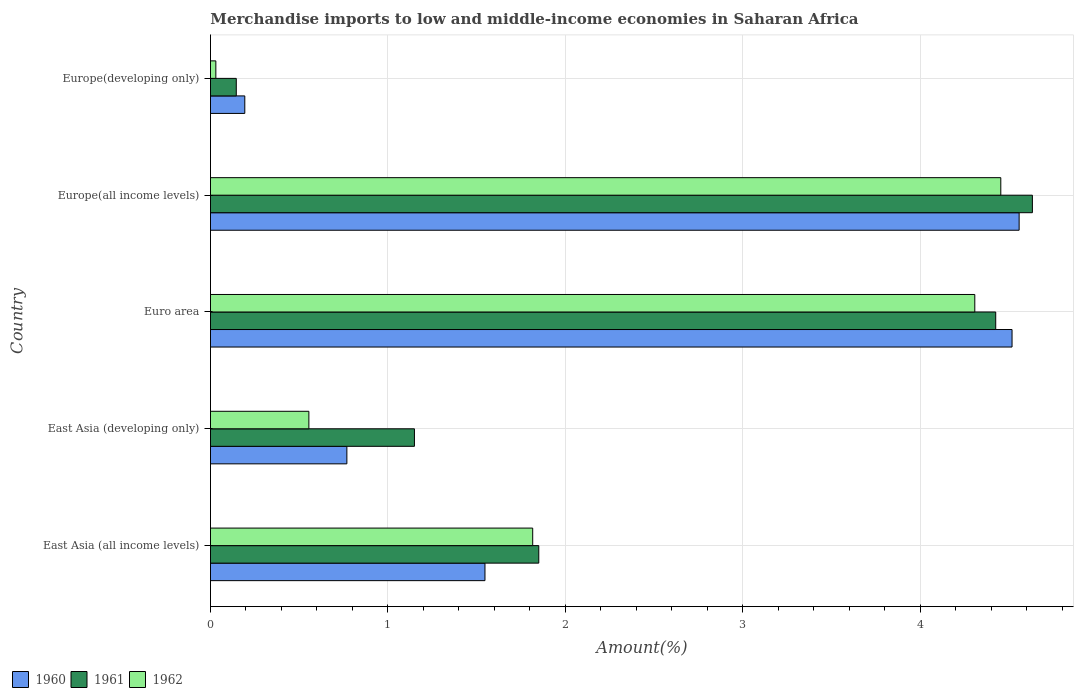How many groups of bars are there?
Your response must be concise. 5. Are the number of bars on each tick of the Y-axis equal?
Offer a very short reply. Yes. How many bars are there on the 2nd tick from the bottom?
Make the answer very short. 3. What is the label of the 4th group of bars from the top?
Ensure brevity in your answer.  East Asia (developing only). In how many cases, is the number of bars for a given country not equal to the number of legend labels?
Provide a succinct answer. 0. What is the percentage of amount earned from merchandise imports in 1962 in Euro area?
Provide a succinct answer. 4.31. Across all countries, what is the maximum percentage of amount earned from merchandise imports in 1962?
Provide a short and direct response. 4.45. Across all countries, what is the minimum percentage of amount earned from merchandise imports in 1962?
Offer a terse response. 0.03. In which country was the percentage of amount earned from merchandise imports in 1962 maximum?
Make the answer very short. Europe(all income levels). In which country was the percentage of amount earned from merchandise imports in 1961 minimum?
Provide a short and direct response. Europe(developing only). What is the total percentage of amount earned from merchandise imports in 1962 in the graph?
Provide a short and direct response. 11.16. What is the difference between the percentage of amount earned from merchandise imports in 1961 in East Asia (developing only) and that in Euro area?
Your answer should be compact. -3.28. What is the difference between the percentage of amount earned from merchandise imports in 1960 in East Asia (all income levels) and the percentage of amount earned from merchandise imports in 1962 in Europe(all income levels)?
Your answer should be very brief. -2.91. What is the average percentage of amount earned from merchandise imports in 1962 per country?
Make the answer very short. 2.23. What is the difference between the percentage of amount earned from merchandise imports in 1960 and percentage of amount earned from merchandise imports in 1961 in Europe(all income levels)?
Give a very brief answer. -0.07. What is the ratio of the percentage of amount earned from merchandise imports in 1961 in Euro area to that in Europe(developing only)?
Your answer should be very brief. 30.42. Is the difference between the percentage of amount earned from merchandise imports in 1960 in East Asia (all income levels) and Euro area greater than the difference between the percentage of amount earned from merchandise imports in 1961 in East Asia (all income levels) and Euro area?
Your answer should be very brief. No. What is the difference between the highest and the second highest percentage of amount earned from merchandise imports in 1961?
Offer a very short reply. 0.21. What is the difference between the highest and the lowest percentage of amount earned from merchandise imports in 1962?
Give a very brief answer. 4.42. What does the 3rd bar from the top in East Asia (developing only) represents?
Your response must be concise. 1960. What does the 2nd bar from the bottom in East Asia (developing only) represents?
Your answer should be compact. 1961. What is the difference between two consecutive major ticks on the X-axis?
Your response must be concise. 1. Are the values on the major ticks of X-axis written in scientific E-notation?
Make the answer very short. No. Does the graph contain any zero values?
Give a very brief answer. No. Where does the legend appear in the graph?
Your answer should be very brief. Bottom left. What is the title of the graph?
Offer a terse response. Merchandise imports to low and middle-income economies in Saharan Africa. Does "1977" appear as one of the legend labels in the graph?
Offer a terse response. No. What is the label or title of the X-axis?
Offer a terse response. Amount(%). What is the Amount(%) of 1960 in East Asia (all income levels)?
Offer a terse response. 1.55. What is the Amount(%) of 1961 in East Asia (all income levels)?
Make the answer very short. 1.85. What is the Amount(%) of 1962 in East Asia (all income levels)?
Give a very brief answer. 1.82. What is the Amount(%) in 1960 in East Asia (developing only)?
Make the answer very short. 0.77. What is the Amount(%) of 1961 in East Asia (developing only)?
Provide a short and direct response. 1.15. What is the Amount(%) in 1962 in East Asia (developing only)?
Keep it short and to the point. 0.55. What is the Amount(%) in 1960 in Euro area?
Your answer should be very brief. 4.52. What is the Amount(%) of 1961 in Euro area?
Keep it short and to the point. 4.43. What is the Amount(%) in 1962 in Euro area?
Offer a very short reply. 4.31. What is the Amount(%) of 1960 in Europe(all income levels)?
Your response must be concise. 4.56. What is the Amount(%) of 1961 in Europe(all income levels)?
Keep it short and to the point. 4.63. What is the Amount(%) of 1962 in Europe(all income levels)?
Make the answer very short. 4.45. What is the Amount(%) in 1960 in Europe(developing only)?
Provide a succinct answer. 0.19. What is the Amount(%) of 1961 in Europe(developing only)?
Give a very brief answer. 0.15. What is the Amount(%) of 1962 in Europe(developing only)?
Provide a short and direct response. 0.03. Across all countries, what is the maximum Amount(%) in 1960?
Make the answer very short. 4.56. Across all countries, what is the maximum Amount(%) of 1961?
Your answer should be very brief. 4.63. Across all countries, what is the maximum Amount(%) of 1962?
Ensure brevity in your answer.  4.45. Across all countries, what is the minimum Amount(%) in 1960?
Offer a terse response. 0.19. Across all countries, what is the minimum Amount(%) of 1961?
Your answer should be very brief. 0.15. Across all countries, what is the minimum Amount(%) of 1962?
Make the answer very short. 0.03. What is the total Amount(%) in 1960 in the graph?
Keep it short and to the point. 11.58. What is the total Amount(%) in 1961 in the graph?
Provide a short and direct response. 12.2. What is the total Amount(%) of 1962 in the graph?
Offer a terse response. 11.16. What is the difference between the Amount(%) of 1960 in East Asia (all income levels) and that in East Asia (developing only)?
Your response must be concise. 0.78. What is the difference between the Amount(%) of 1961 in East Asia (all income levels) and that in East Asia (developing only)?
Your answer should be very brief. 0.7. What is the difference between the Amount(%) of 1962 in East Asia (all income levels) and that in East Asia (developing only)?
Offer a terse response. 1.26. What is the difference between the Amount(%) of 1960 in East Asia (all income levels) and that in Euro area?
Your response must be concise. -2.97. What is the difference between the Amount(%) in 1961 in East Asia (all income levels) and that in Euro area?
Provide a succinct answer. -2.58. What is the difference between the Amount(%) in 1962 in East Asia (all income levels) and that in Euro area?
Your response must be concise. -2.49. What is the difference between the Amount(%) in 1960 in East Asia (all income levels) and that in Europe(all income levels)?
Provide a succinct answer. -3.01. What is the difference between the Amount(%) of 1961 in East Asia (all income levels) and that in Europe(all income levels)?
Keep it short and to the point. -2.78. What is the difference between the Amount(%) of 1962 in East Asia (all income levels) and that in Europe(all income levels)?
Your response must be concise. -2.64. What is the difference between the Amount(%) of 1960 in East Asia (all income levels) and that in Europe(developing only)?
Give a very brief answer. 1.35. What is the difference between the Amount(%) in 1961 in East Asia (all income levels) and that in Europe(developing only)?
Make the answer very short. 1.7. What is the difference between the Amount(%) of 1962 in East Asia (all income levels) and that in Europe(developing only)?
Your answer should be very brief. 1.79. What is the difference between the Amount(%) of 1960 in East Asia (developing only) and that in Euro area?
Your answer should be compact. -3.75. What is the difference between the Amount(%) of 1961 in East Asia (developing only) and that in Euro area?
Provide a succinct answer. -3.28. What is the difference between the Amount(%) of 1962 in East Asia (developing only) and that in Euro area?
Keep it short and to the point. -3.75. What is the difference between the Amount(%) of 1960 in East Asia (developing only) and that in Europe(all income levels)?
Give a very brief answer. -3.79. What is the difference between the Amount(%) in 1961 in East Asia (developing only) and that in Europe(all income levels)?
Offer a terse response. -3.48. What is the difference between the Amount(%) in 1962 in East Asia (developing only) and that in Europe(all income levels)?
Provide a succinct answer. -3.9. What is the difference between the Amount(%) of 1960 in East Asia (developing only) and that in Europe(developing only)?
Give a very brief answer. 0.58. What is the difference between the Amount(%) in 1962 in East Asia (developing only) and that in Europe(developing only)?
Your response must be concise. 0.52. What is the difference between the Amount(%) in 1960 in Euro area and that in Europe(all income levels)?
Your response must be concise. -0.04. What is the difference between the Amount(%) in 1961 in Euro area and that in Europe(all income levels)?
Provide a short and direct response. -0.21. What is the difference between the Amount(%) of 1962 in Euro area and that in Europe(all income levels)?
Your answer should be compact. -0.15. What is the difference between the Amount(%) of 1960 in Euro area and that in Europe(developing only)?
Keep it short and to the point. 4.32. What is the difference between the Amount(%) of 1961 in Euro area and that in Europe(developing only)?
Offer a very short reply. 4.28. What is the difference between the Amount(%) of 1962 in Euro area and that in Europe(developing only)?
Keep it short and to the point. 4.28. What is the difference between the Amount(%) of 1960 in Europe(all income levels) and that in Europe(developing only)?
Offer a very short reply. 4.36. What is the difference between the Amount(%) of 1961 in Europe(all income levels) and that in Europe(developing only)?
Your response must be concise. 4.49. What is the difference between the Amount(%) of 1962 in Europe(all income levels) and that in Europe(developing only)?
Make the answer very short. 4.42. What is the difference between the Amount(%) in 1960 in East Asia (all income levels) and the Amount(%) in 1961 in East Asia (developing only)?
Provide a succinct answer. 0.4. What is the difference between the Amount(%) of 1961 in East Asia (all income levels) and the Amount(%) of 1962 in East Asia (developing only)?
Your answer should be compact. 1.3. What is the difference between the Amount(%) in 1960 in East Asia (all income levels) and the Amount(%) in 1961 in Euro area?
Keep it short and to the point. -2.88. What is the difference between the Amount(%) of 1960 in East Asia (all income levels) and the Amount(%) of 1962 in Euro area?
Ensure brevity in your answer.  -2.76. What is the difference between the Amount(%) of 1961 in East Asia (all income levels) and the Amount(%) of 1962 in Euro area?
Keep it short and to the point. -2.46. What is the difference between the Amount(%) of 1960 in East Asia (all income levels) and the Amount(%) of 1961 in Europe(all income levels)?
Ensure brevity in your answer.  -3.08. What is the difference between the Amount(%) of 1960 in East Asia (all income levels) and the Amount(%) of 1962 in Europe(all income levels)?
Your answer should be compact. -2.91. What is the difference between the Amount(%) in 1961 in East Asia (all income levels) and the Amount(%) in 1962 in Europe(all income levels)?
Ensure brevity in your answer.  -2.6. What is the difference between the Amount(%) in 1960 in East Asia (all income levels) and the Amount(%) in 1961 in Europe(developing only)?
Your response must be concise. 1.4. What is the difference between the Amount(%) of 1960 in East Asia (all income levels) and the Amount(%) of 1962 in Europe(developing only)?
Ensure brevity in your answer.  1.52. What is the difference between the Amount(%) in 1961 in East Asia (all income levels) and the Amount(%) in 1962 in Europe(developing only)?
Give a very brief answer. 1.82. What is the difference between the Amount(%) in 1960 in East Asia (developing only) and the Amount(%) in 1961 in Euro area?
Give a very brief answer. -3.66. What is the difference between the Amount(%) of 1960 in East Asia (developing only) and the Amount(%) of 1962 in Euro area?
Make the answer very short. -3.54. What is the difference between the Amount(%) of 1961 in East Asia (developing only) and the Amount(%) of 1962 in Euro area?
Your response must be concise. -3.16. What is the difference between the Amount(%) in 1960 in East Asia (developing only) and the Amount(%) in 1961 in Europe(all income levels)?
Provide a short and direct response. -3.86. What is the difference between the Amount(%) of 1960 in East Asia (developing only) and the Amount(%) of 1962 in Europe(all income levels)?
Keep it short and to the point. -3.68. What is the difference between the Amount(%) in 1961 in East Asia (developing only) and the Amount(%) in 1962 in Europe(all income levels)?
Provide a short and direct response. -3.3. What is the difference between the Amount(%) of 1960 in East Asia (developing only) and the Amount(%) of 1961 in Europe(developing only)?
Offer a very short reply. 0.62. What is the difference between the Amount(%) in 1960 in East Asia (developing only) and the Amount(%) in 1962 in Europe(developing only)?
Provide a succinct answer. 0.74. What is the difference between the Amount(%) of 1961 in East Asia (developing only) and the Amount(%) of 1962 in Europe(developing only)?
Your answer should be very brief. 1.12. What is the difference between the Amount(%) in 1960 in Euro area and the Amount(%) in 1961 in Europe(all income levels)?
Ensure brevity in your answer.  -0.11. What is the difference between the Amount(%) of 1960 in Euro area and the Amount(%) of 1962 in Europe(all income levels)?
Offer a terse response. 0.06. What is the difference between the Amount(%) in 1961 in Euro area and the Amount(%) in 1962 in Europe(all income levels)?
Make the answer very short. -0.03. What is the difference between the Amount(%) of 1960 in Euro area and the Amount(%) of 1961 in Europe(developing only)?
Offer a terse response. 4.37. What is the difference between the Amount(%) in 1960 in Euro area and the Amount(%) in 1962 in Europe(developing only)?
Provide a succinct answer. 4.49. What is the difference between the Amount(%) in 1961 in Euro area and the Amount(%) in 1962 in Europe(developing only)?
Your answer should be compact. 4.39. What is the difference between the Amount(%) of 1960 in Europe(all income levels) and the Amount(%) of 1961 in Europe(developing only)?
Your answer should be very brief. 4.41. What is the difference between the Amount(%) in 1960 in Europe(all income levels) and the Amount(%) in 1962 in Europe(developing only)?
Provide a succinct answer. 4.53. What is the difference between the Amount(%) in 1961 in Europe(all income levels) and the Amount(%) in 1962 in Europe(developing only)?
Your answer should be very brief. 4.6. What is the average Amount(%) of 1960 per country?
Your answer should be very brief. 2.32. What is the average Amount(%) in 1961 per country?
Offer a very short reply. 2.44. What is the average Amount(%) of 1962 per country?
Offer a very short reply. 2.23. What is the difference between the Amount(%) of 1960 and Amount(%) of 1961 in East Asia (all income levels)?
Keep it short and to the point. -0.3. What is the difference between the Amount(%) in 1960 and Amount(%) in 1962 in East Asia (all income levels)?
Make the answer very short. -0.27. What is the difference between the Amount(%) in 1961 and Amount(%) in 1962 in East Asia (all income levels)?
Your response must be concise. 0.03. What is the difference between the Amount(%) of 1960 and Amount(%) of 1961 in East Asia (developing only)?
Your response must be concise. -0.38. What is the difference between the Amount(%) in 1960 and Amount(%) in 1962 in East Asia (developing only)?
Make the answer very short. 0.21. What is the difference between the Amount(%) in 1961 and Amount(%) in 1962 in East Asia (developing only)?
Your answer should be compact. 0.59. What is the difference between the Amount(%) of 1960 and Amount(%) of 1961 in Euro area?
Give a very brief answer. 0.09. What is the difference between the Amount(%) of 1960 and Amount(%) of 1962 in Euro area?
Make the answer very short. 0.21. What is the difference between the Amount(%) of 1961 and Amount(%) of 1962 in Euro area?
Provide a succinct answer. 0.12. What is the difference between the Amount(%) of 1960 and Amount(%) of 1961 in Europe(all income levels)?
Your response must be concise. -0.07. What is the difference between the Amount(%) of 1960 and Amount(%) of 1962 in Europe(all income levels)?
Give a very brief answer. 0.1. What is the difference between the Amount(%) in 1961 and Amount(%) in 1962 in Europe(all income levels)?
Provide a short and direct response. 0.18. What is the difference between the Amount(%) of 1960 and Amount(%) of 1961 in Europe(developing only)?
Provide a succinct answer. 0.05. What is the difference between the Amount(%) of 1960 and Amount(%) of 1962 in Europe(developing only)?
Offer a terse response. 0.16. What is the difference between the Amount(%) in 1961 and Amount(%) in 1962 in Europe(developing only)?
Ensure brevity in your answer.  0.12. What is the ratio of the Amount(%) of 1960 in East Asia (all income levels) to that in East Asia (developing only)?
Your response must be concise. 2.01. What is the ratio of the Amount(%) of 1961 in East Asia (all income levels) to that in East Asia (developing only)?
Give a very brief answer. 1.61. What is the ratio of the Amount(%) in 1962 in East Asia (all income levels) to that in East Asia (developing only)?
Offer a terse response. 3.27. What is the ratio of the Amount(%) of 1960 in East Asia (all income levels) to that in Euro area?
Your response must be concise. 0.34. What is the ratio of the Amount(%) of 1961 in East Asia (all income levels) to that in Euro area?
Ensure brevity in your answer.  0.42. What is the ratio of the Amount(%) of 1962 in East Asia (all income levels) to that in Euro area?
Offer a terse response. 0.42. What is the ratio of the Amount(%) in 1960 in East Asia (all income levels) to that in Europe(all income levels)?
Provide a short and direct response. 0.34. What is the ratio of the Amount(%) in 1961 in East Asia (all income levels) to that in Europe(all income levels)?
Keep it short and to the point. 0.4. What is the ratio of the Amount(%) of 1962 in East Asia (all income levels) to that in Europe(all income levels)?
Make the answer very short. 0.41. What is the ratio of the Amount(%) in 1960 in East Asia (all income levels) to that in Europe(developing only)?
Give a very brief answer. 8. What is the ratio of the Amount(%) in 1961 in East Asia (all income levels) to that in Europe(developing only)?
Keep it short and to the point. 12.72. What is the ratio of the Amount(%) of 1962 in East Asia (all income levels) to that in Europe(developing only)?
Your answer should be very brief. 59.99. What is the ratio of the Amount(%) of 1960 in East Asia (developing only) to that in Euro area?
Offer a terse response. 0.17. What is the ratio of the Amount(%) in 1961 in East Asia (developing only) to that in Euro area?
Ensure brevity in your answer.  0.26. What is the ratio of the Amount(%) in 1962 in East Asia (developing only) to that in Euro area?
Ensure brevity in your answer.  0.13. What is the ratio of the Amount(%) of 1960 in East Asia (developing only) to that in Europe(all income levels)?
Offer a terse response. 0.17. What is the ratio of the Amount(%) in 1961 in East Asia (developing only) to that in Europe(all income levels)?
Your response must be concise. 0.25. What is the ratio of the Amount(%) of 1962 in East Asia (developing only) to that in Europe(all income levels)?
Provide a short and direct response. 0.12. What is the ratio of the Amount(%) of 1960 in East Asia (developing only) to that in Europe(developing only)?
Ensure brevity in your answer.  3.97. What is the ratio of the Amount(%) in 1961 in East Asia (developing only) to that in Europe(developing only)?
Make the answer very short. 7.9. What is the ratio of the Amount(%) in 1962 in East Asia (developing only) to that in Europe(developing only)?
Offer a very short reply. 18.32. What is the ratio of the Amount(%) of 1960 in Euro area to that in Europe(all income levels)?
Provide a succinct answer. 0.99. What is the ratio of the Amount(%) of 1961 in Euro area to that in Europe(all income levels)?
Provide a succinct answer. 0.96. What is the ratio of the Amount(%) of 1962 in Euro area to that in Europe(all income levels)?
Ensure brevity in your answer.  0.97. What is the ratio of the Amount(%) in 1960 in Euro area to that in Europe(developing only)?
Your response must be concise. 23.36. What is the ratio of the Amount(%) of 1961 in Euro area to that in Europe(developing only)?
Provide a succinct answer. 30.42. What is the ratio of the Amount(%) in 1962 in Euro area to that in Europe(developing only)?
Keep it short and to the point. 142.3. What is the ratio of the Amount(%) of 1960 in Europe(all income levels) to that in Europe(developing only)?
Offer a very short reply. 23.56. What is the ratio of the Amount(%) of 1961 in Europe(all income levels) to that in Europe(developing only)?
Offer a very short reply. 31.84. What is the ratio of the Amount(%) of 1962 in Europe(all income levels) to that in Europe(developing only)?
Ensure brevity in your answer.  147.14. What is the difference between the highest and the second highest Amount(%) in 1960?
Ensure brevity in your answer.  0.04. What is the difference between the highest and the second highest Amount(%) in 1961?
Make the answer very short. 0.21. What is the difference between the highest and the second highest Amount(%) of 1962?
Offer a very short reply. 0.15. What is the difference between the highest and the lowest Amount(%) of 1960?
Give a very brief answer. 4.36. What is the difference between the highest and the lowest Amount(%) in 1961?
Offer a terse response. 4.49. What is the difference between the highest and the lowest Amount(%) of 1962?
Your answer should be very brief. 4.42. 